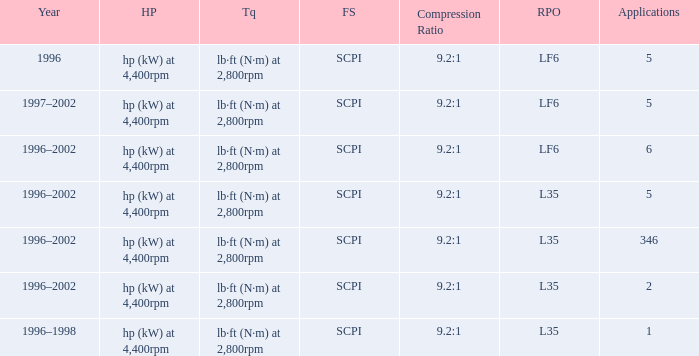What are the torque characteristics of the model made in 1996? Lb·ft (n·m) at 2,800rpm. 